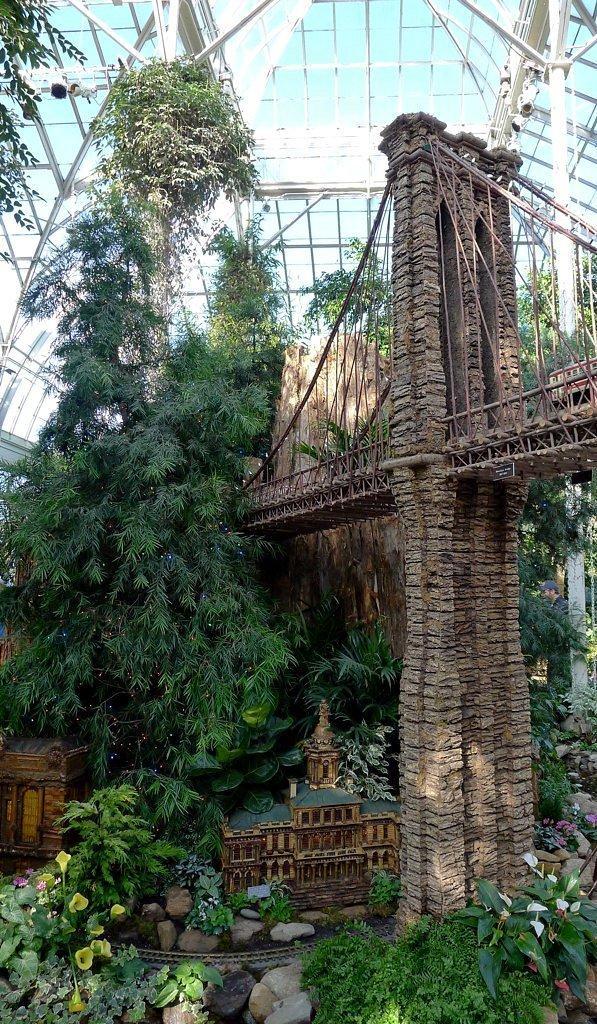Describe this image in one or two sentences. In this image there are many trees and plants with flowers, leaves, stems and branches. There are a few pebbles. On the right side of the image there is a bridge. At the top of the image there is a roof. Through the roof we can see there is the sky. 